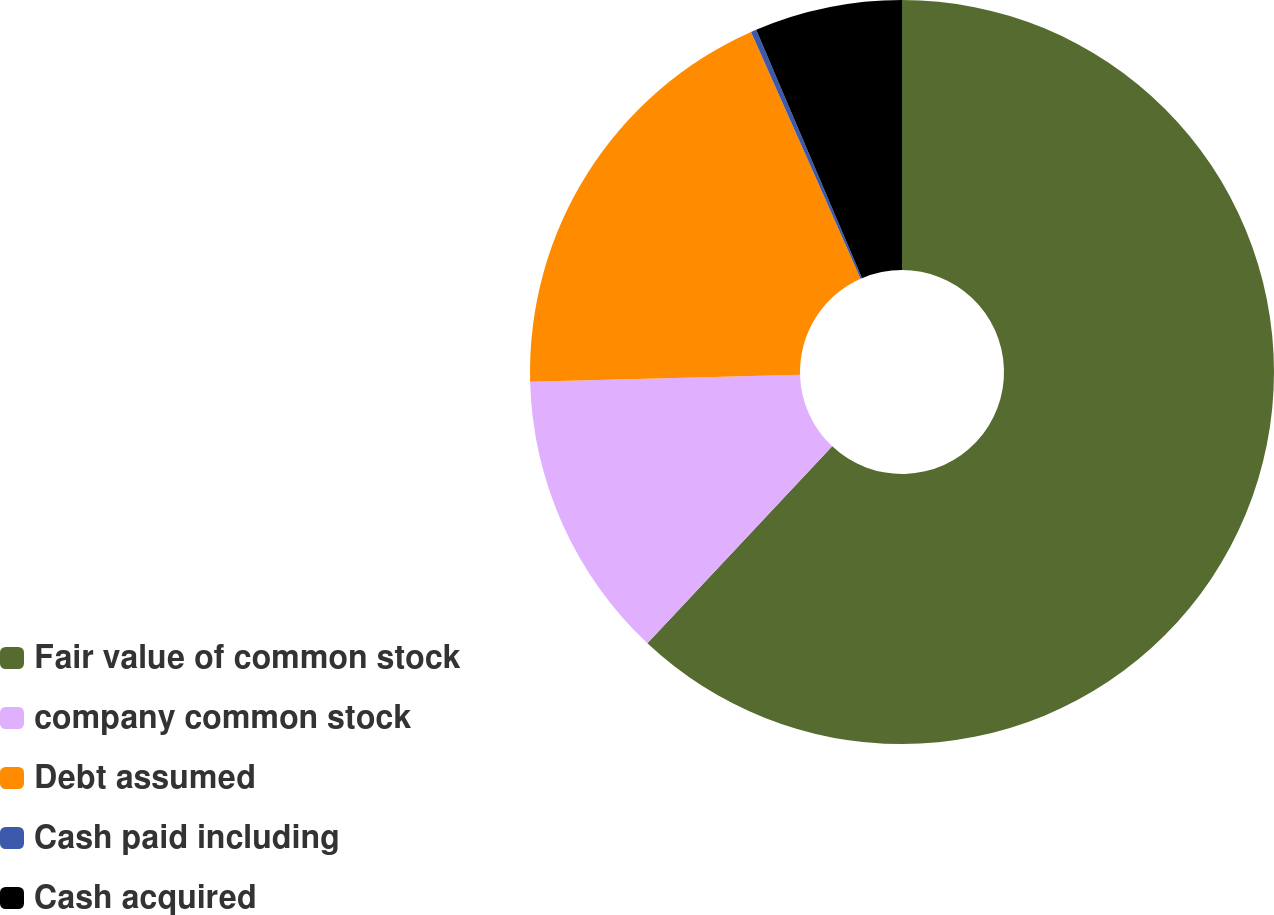Convert chart to OTSL. <chart><loc_0><loc_0><loc_500><loc_500><pie_chart><fcel>Fair value of common stock<fcel>company common stock<fcel>Debt assumed<fcel>Cash paid including<fcel>Cash acquired<nl><fcel>61.99%<fcel>12.59%<fcel>18.76%<fcel>0.24%<fcel>6.41%<nl></chart> 